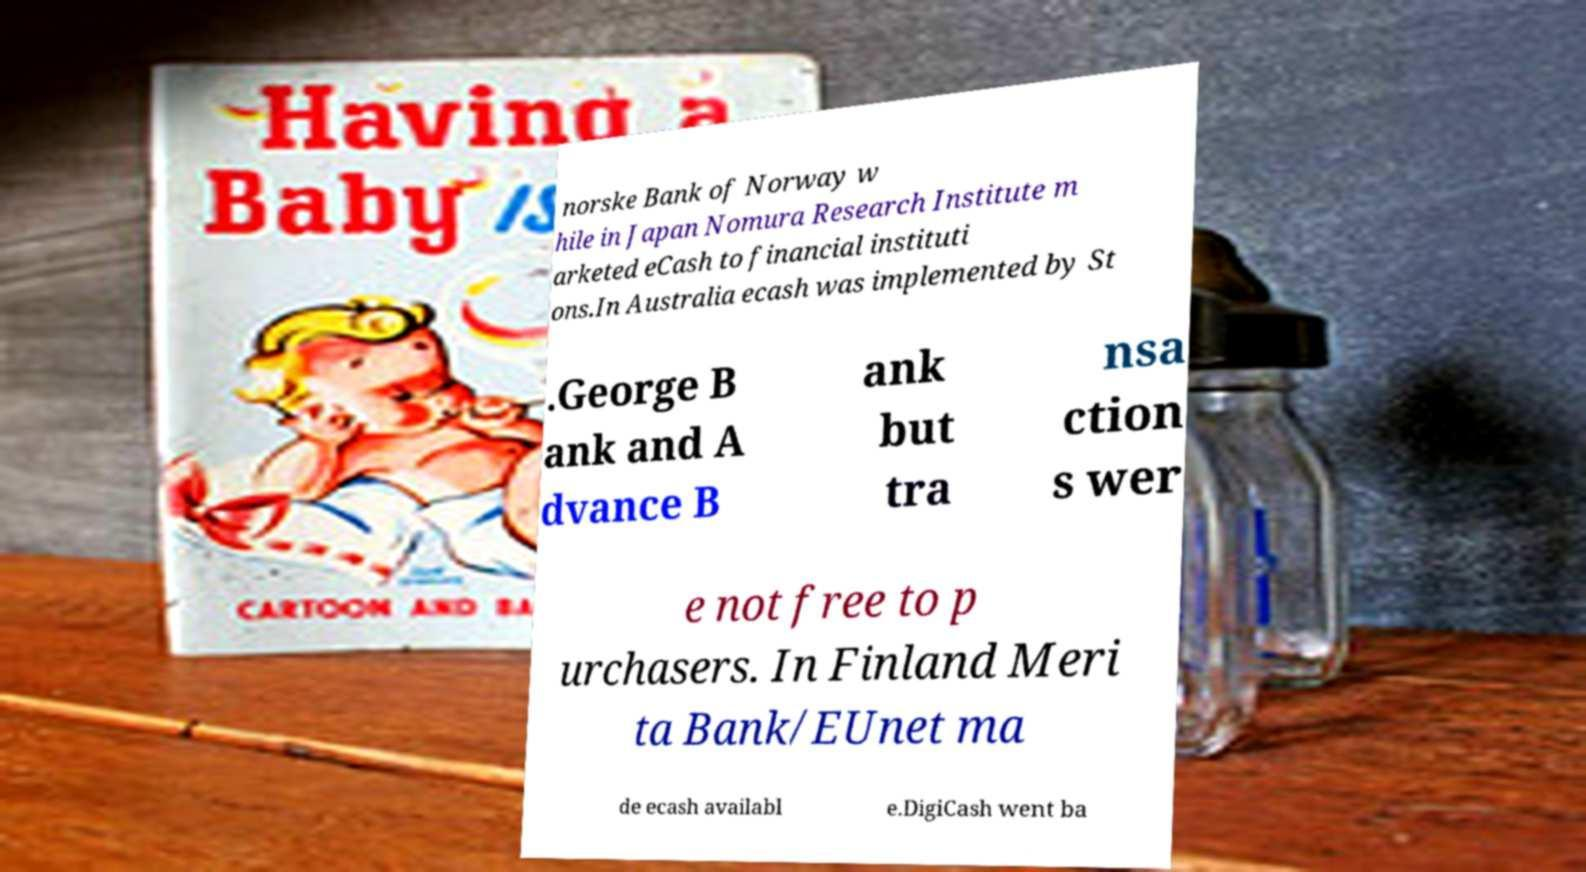Could you assist in decoding the text presented in this image and type it out clearly? norske Bank of Norway w hile in Japan Nomura Research Institute m arketed eCash to financial instituti ons.In Australia ecash was implemented by St .George B ank and A dvance B ank but tra nsa ction s wer e not free to p urchasers. In Finland Meri ta Bank/EUnet ma de ecash availabl e.DigiCash went ba 